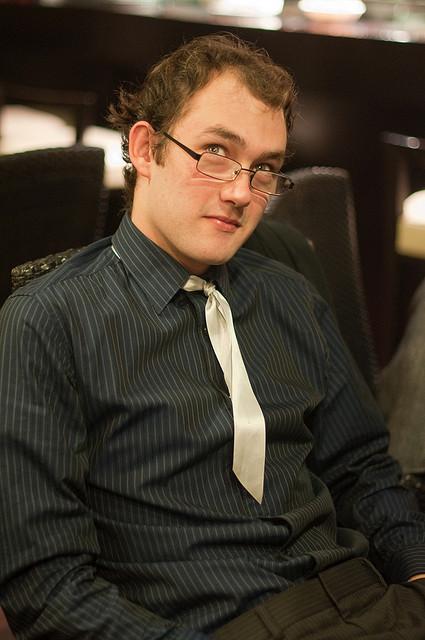What color is the boy's tie?
Concise answer only. White. Is the man wearing glasses?
Be succinct. Yes. How old is the man in the picture?
Short answer required. 22. Does this man look cold?
Write a very short answer. No. What color is the tie?
Answer briefly. White. IS the man handsome?
Concise answer only. Yes. Is this man listening to something?
Short answer required. Yes. What is on the side of his face?
Concise answer only. Glasses. Does this man enjoy sushi?
Keep it brief. Yes. What color is the man's tie?
Keep it brief. White. What color is the sunglasses lens?
Keep it brief. Clear. Is the man awake?
Short answer required. Yes. What is in the boys ear?
Concise answer only. Nothing. Does this man have facial hair?
Give a very brief answer. No. What gender is this person?
Concise answer only. Male. What sort of facial hair does this man have?
Give a very brief answer. None. What is the man doing?
Answer briefly. Sitting. 